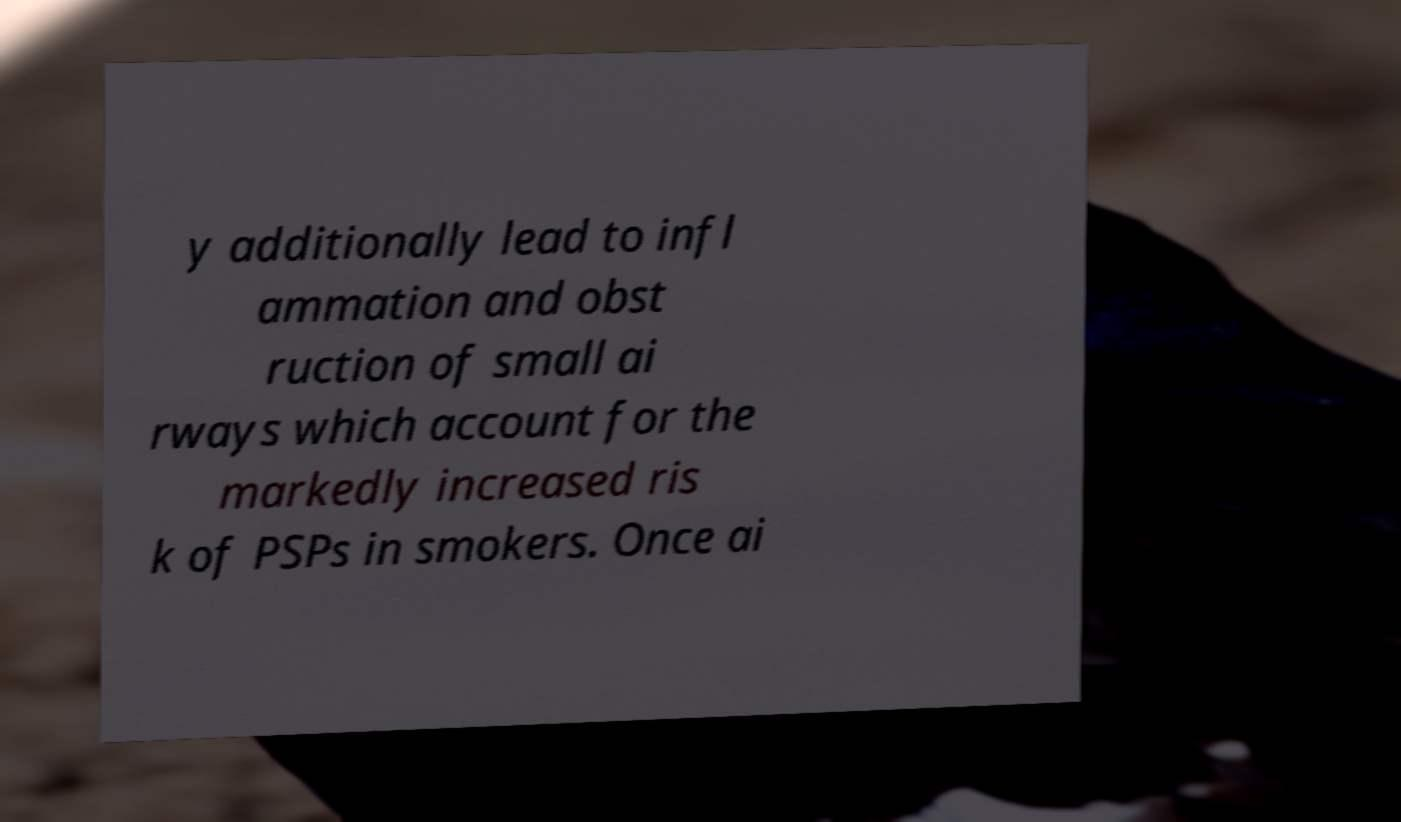What messages or text are displayed in this image? I need them in a readable, typed format. y additionally lead to infl ammation and obst ruction of small ai rways which account for the markedly increased ris k of PSPs in smokers. Once ai 